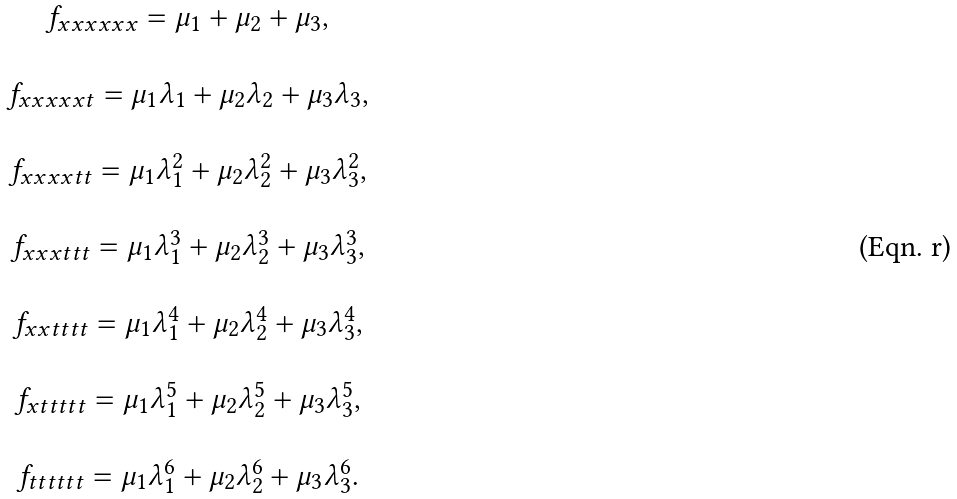<formula> <loc_0><loc_0><loc_500><loc_500>\begin{array} { c } f _ { x x x x x x } = \mu _ { 1 } + \mu _ { 2 } + \mu _ { 3 } , \\ \ \\ f _ { x x x x x t } = \mu _ { 1 } \lambda _ { 1 } + \mu _ { 2 } \lambda _ { 2 } + \mu _ { 3 } \lambda _ { 3 } , \\ \ \\ f _ { x x x x t t } = \mu _ { 1 } \lambda _ { 1 } ^ { 2 } + \mu _ { 2 } \lambda _ { 2 } ^ { 2 } + \mu _ { 3 } \lambda _ { 3 } ^ { 2 } , \\ \ \\ f _ { x x x t t t } = \mu _ { 1 } \lambda _ { 1 } ^ { 3 } + \mu _ { 2 } \lambda _ { 2 } ^ { 3 } + \mu _ { 3 } \lambda _ { 3 } ^ { 3 } , \\ \ \\ f _ { x x t t t t } = \mu _ { 1 } \lambda _ { 1 } ^ { 4 } + \mu _ { 2 } \lambda _ { 2 } ^ { 4 } + \mu _ { 3 } \lambda _ { 3 } ^ { 4 } , \\ \ \\ f _ { x t t t t t } = \mu _ { 1 } \lambda _ { 1 } ^ { 5 } + \mu _ { 2 } \lambda _ { 2 } ^ { 5 } + \mu _ { 3 } \lambda _ { 3 } ^ { 5 } , \\ \ \\ f _ { t t t t t t } = \mu _ { 1 } \lambda _ { 1 } ^ { 6 } + \mu _ { 2 } \lambda _ { 2 } ^ { 6 } + \mu _ { 3 } \lambda _ { 3 } ^ { 6 } . \\ \end{array}</formula> 